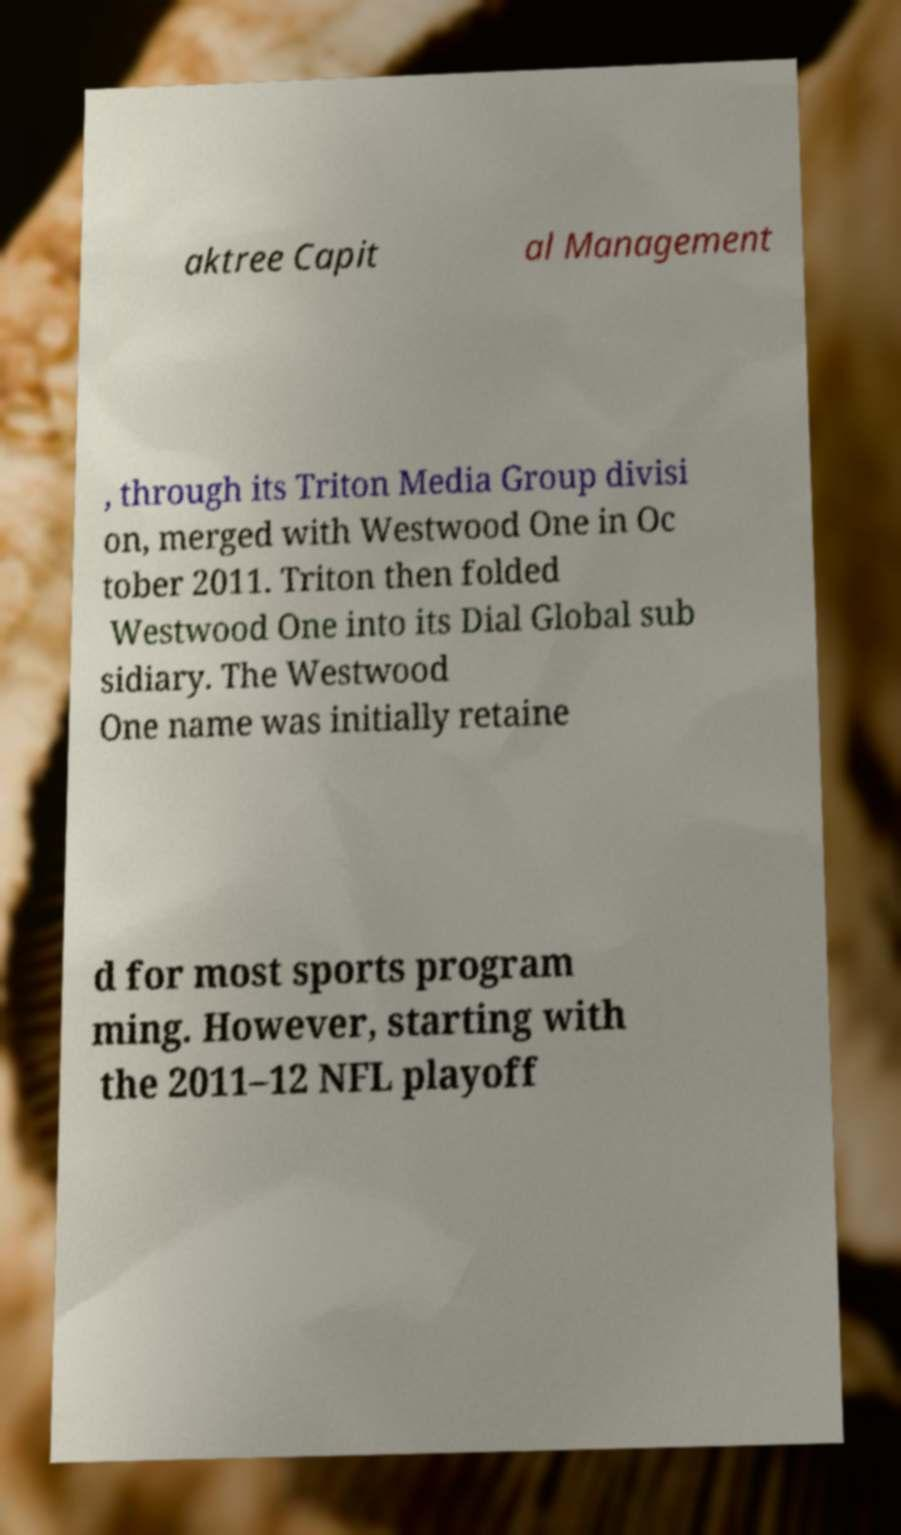Please read and relay the text visible in this image. What does it say? aktree Capit al Management , through its Triton Media Group divisi on, merged with Westwood One in Oc tober 2011. Triton then folded Westwood One into its Dial Global sub sidiary. The Westwood One name was initially retaine d for most sports program ming. However, starting with the 2011–12 NFL playoff 